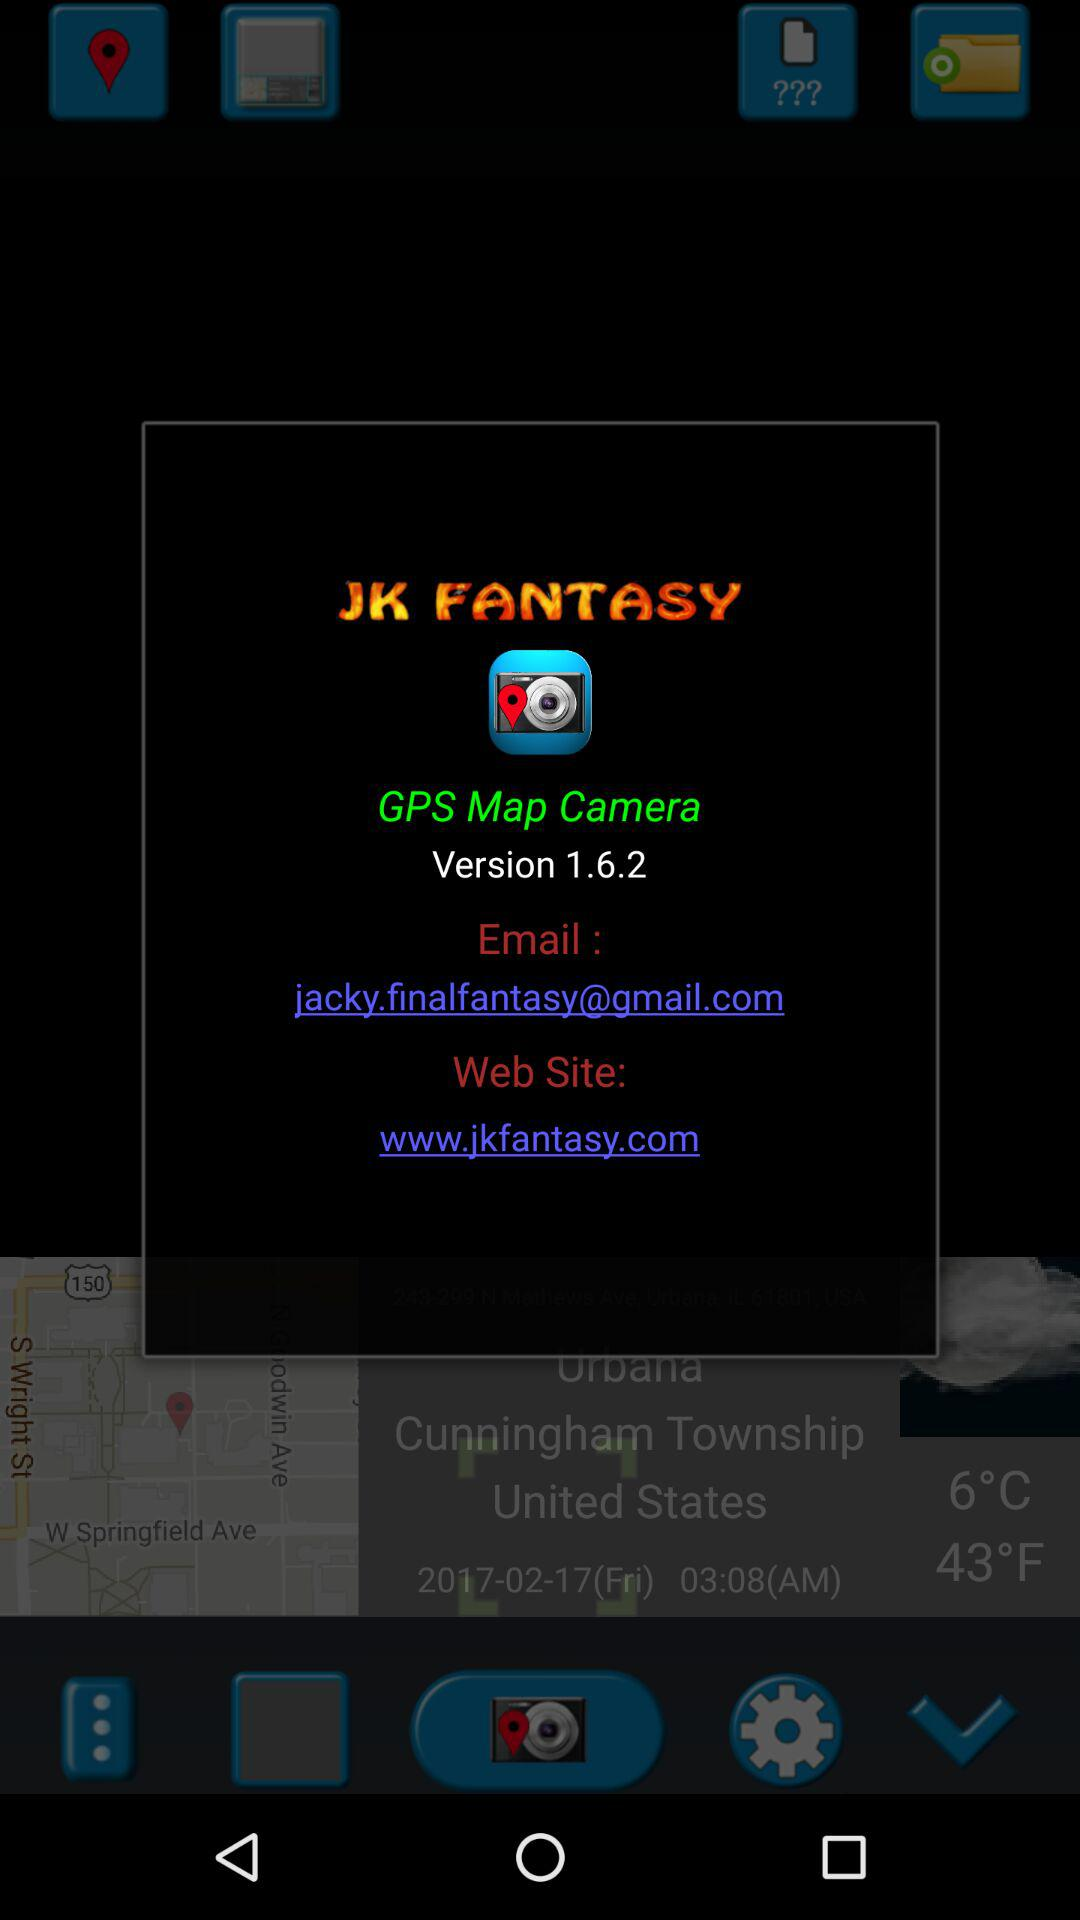What is the name of the application? The name of the application is "GPS Map Camera". 